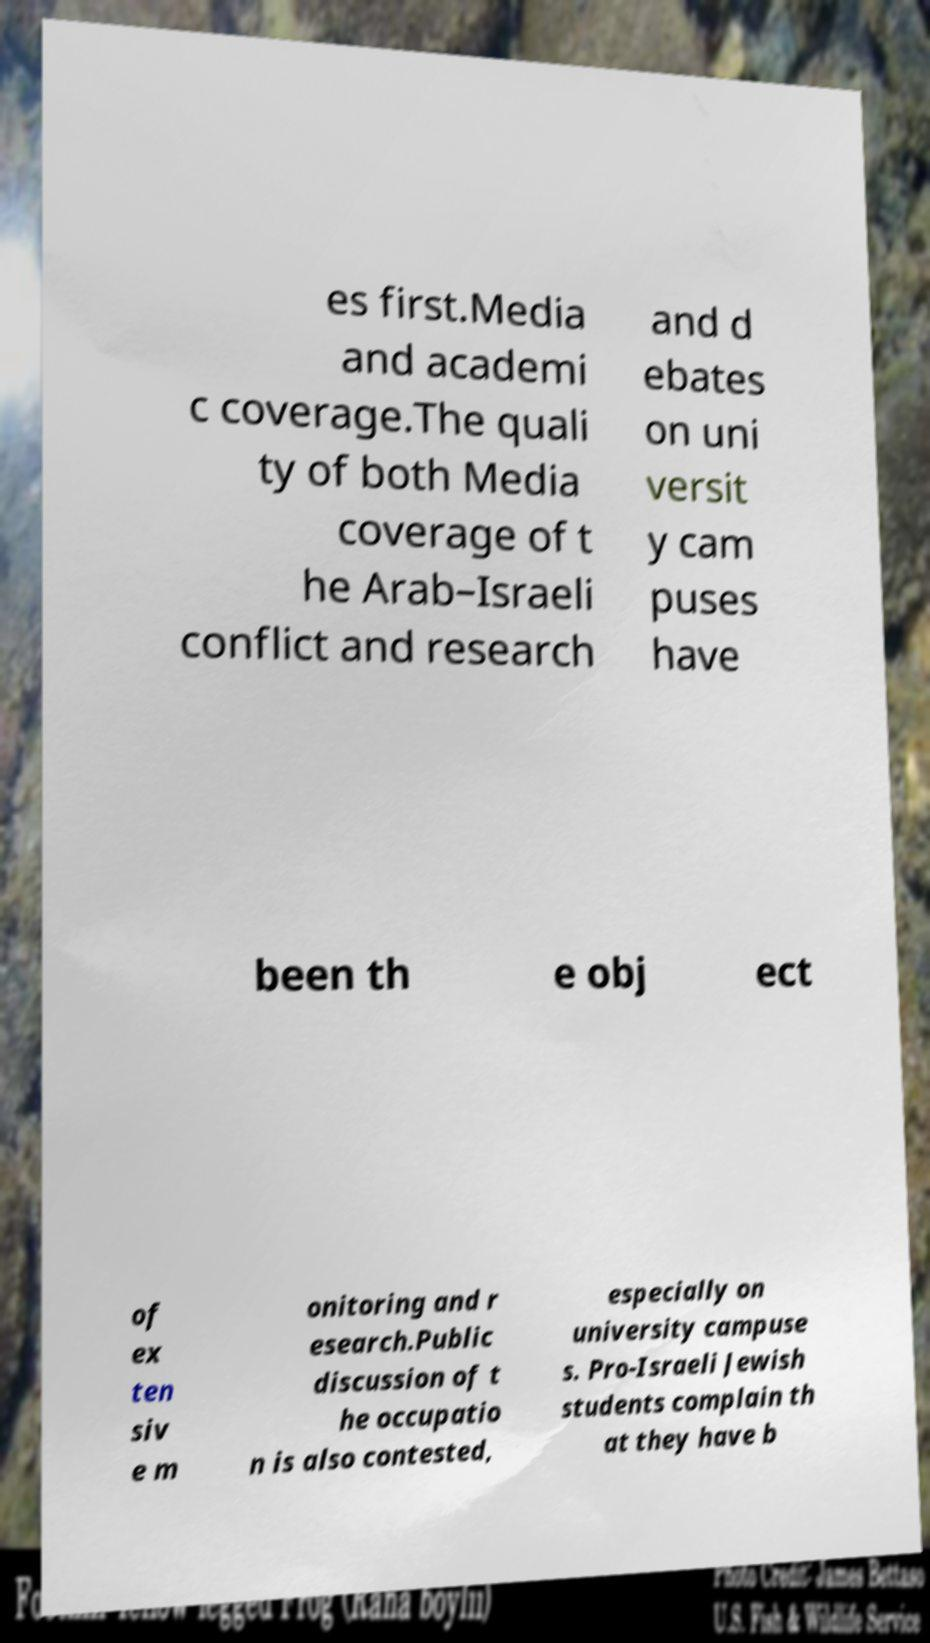What messages or text are displayed in this image? I need them in a readable, typed format. es first.Media and academi c coverage.The quali ty of both Media coverage of t he Arab–Israeli conflict and research and d ebates on uni versit y cam puses have been th e obj ect of ex ten siv e m onitoring and r esearch.Public discussion of t he occupatio n is also contested, especially on university campuse s. Pro-Israeli Jewish students complain th at they have b 